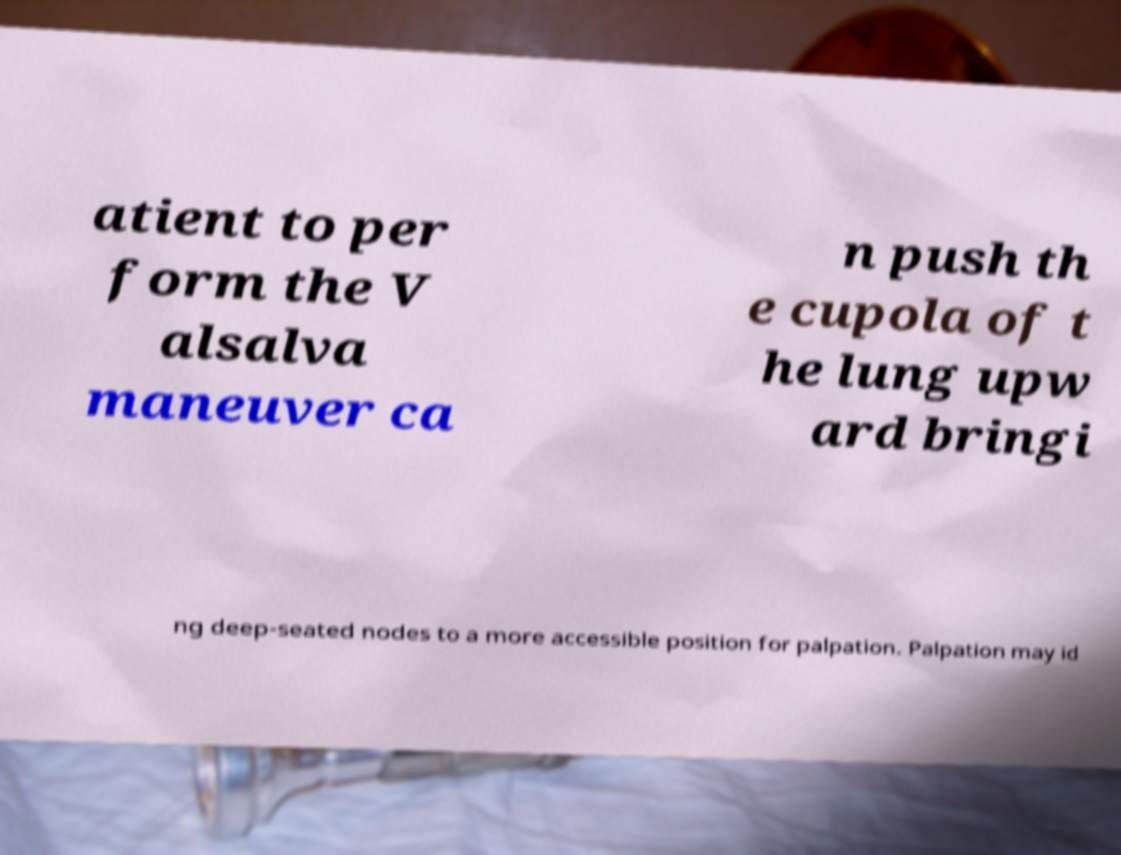Please identify and transcribe the text found in this image. atient to per form the V alsalva maneuver ca n push th e cupola of t he lung upw ard bringi ng deep-seated nodes to a more accessible position for palpation. Palpation may id 